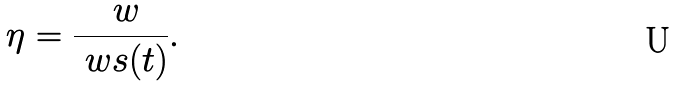Convert formula to latex. <formula><loc_0><loc_0><loc_500><loc_500>\eta = \frac { \ w } { \ w s ( t ) } .</formula> 